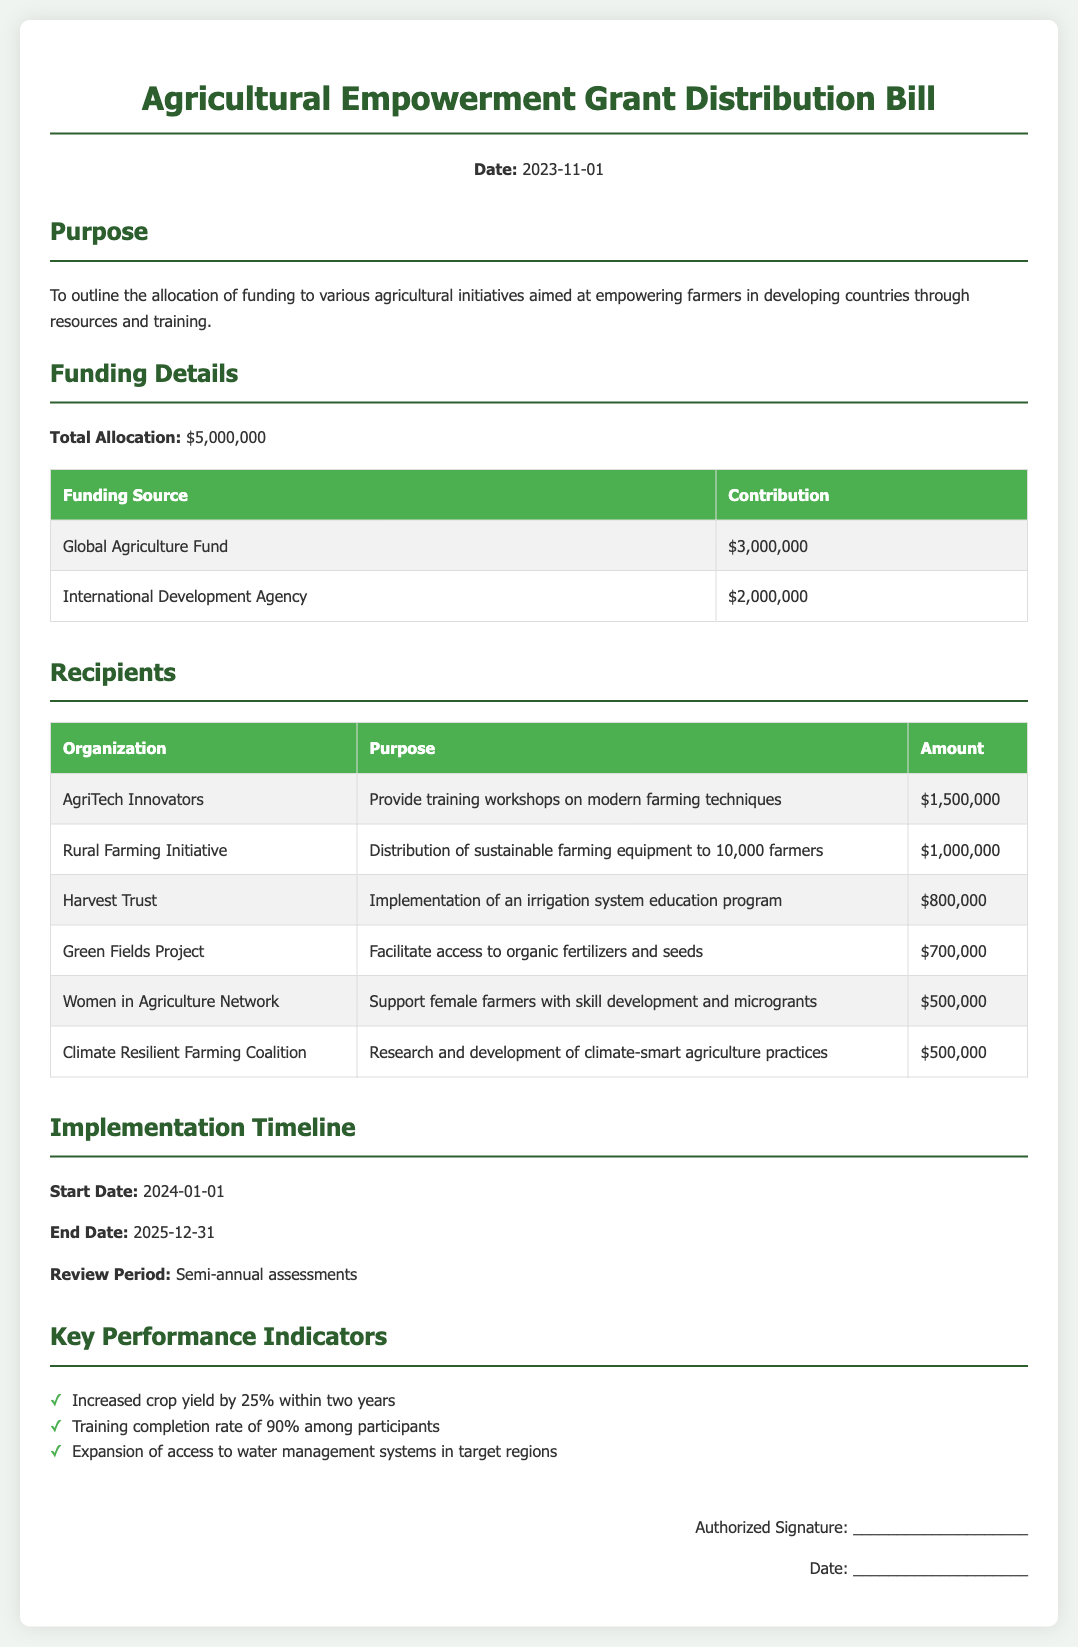What is the total allocation? The total allocation is clearly stated in the document as $5,000,000.
Answer: $5,000,000 Who is receiving the largest grant? The organization receiving the largest grant can be found in the recipients section, which is AgriTech Innovators with $1,500,000.
Answer: AgriTech Innovators What is the purpose of the Rural Farming Initiative? The purpose of the Rural Farming Initiative is detailed in the recipients section, specifically for distributing sustainable farming equipment to 10,000 farmers.
Answer: Distribution of sustainable farming equipment to 10,000 farmers What is the end date of the implementation timeline? The document specifies that the end date of the implementation timeline is December 31, 2025.
Answer: 2025-12-31 How much funding is allocated for climate-smart agriculture practices? The allotted funding for researching and developing climate-smart agriculture practices is included in the recipients section, which is $500,000.
Answer: $500,000 What percentage of crop yield increase is targeted within two years? The key performance indicator for crop yield increase is identified in the document as 25%.
Answer: 25% How often will assessments be reviewed? The document states that assessments will be reviewed semi-annually.
Answer: Semi-annual What contributions does the Global Agriculture Fund provide? The funding details section lists the Global Agriculture Fund contribution as $3,000,000.
Answer: $3,000,000 What initiative supports female farmers? According to the recipients section, the initiative that supports female farmers is the Women in Agriculture Network.
Answer: Women in Agriculture Network 